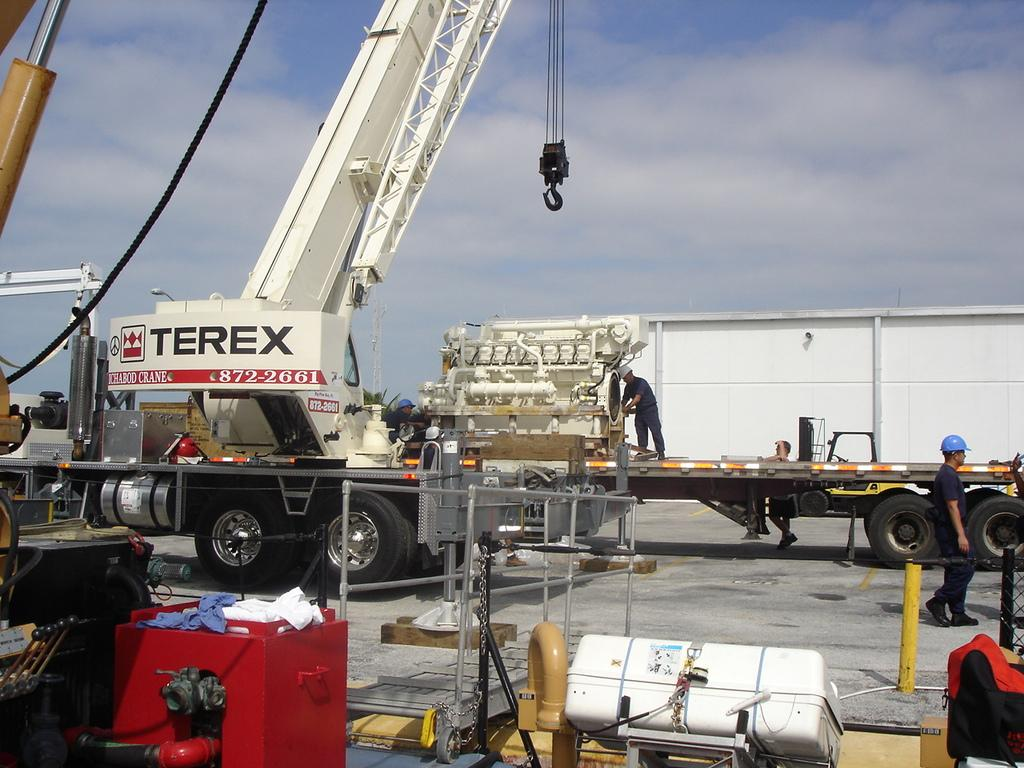What types of subjects can be seen in the image? There are people and vehicles in the image. Can you describe any specific objects in the image? There is a rope, a red box, clothes, a fence, rods, and a chain in the image. What is visible in the background of the image? The sky with clouds is visible in the background of the image. What type of feast is being prepared in the image? There is no indication of a feast being prepared in the image. Can you tell me a joke that is related to the image? There is no joke related to the image, as the conversation is focused on describing the contents of the image. Are there any icicles visible in the image? There is no mention of icicles in the image, and they are not visible in the provided facts. 